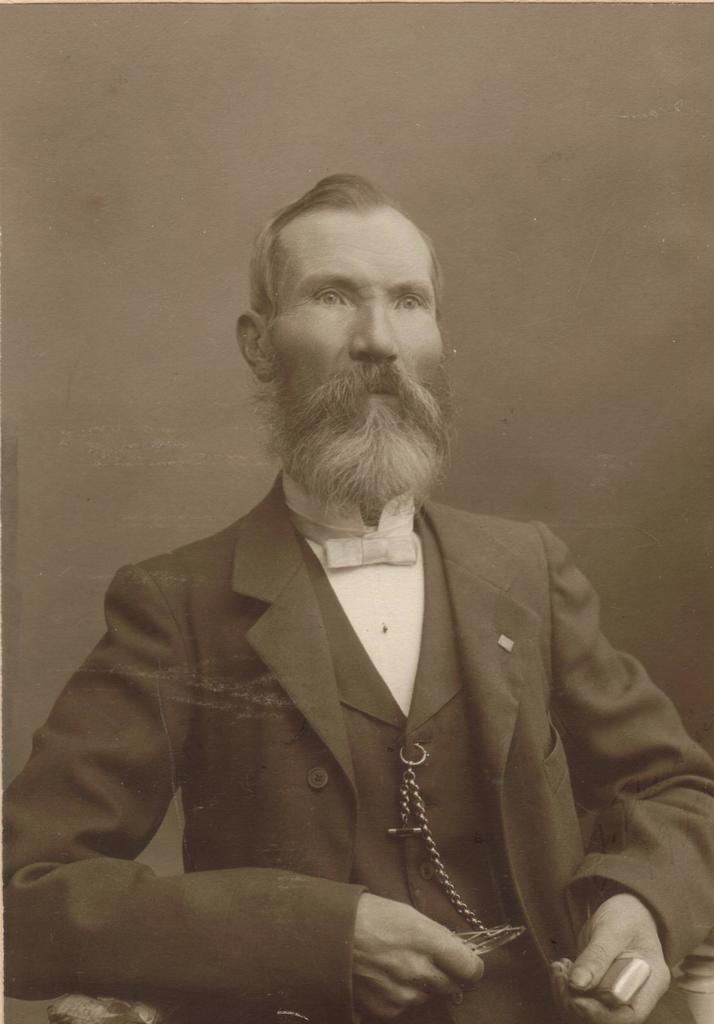Describe this image in one or two sentences. This is a black and white image. In this image we can see a man. And he is holding something in the hands. 